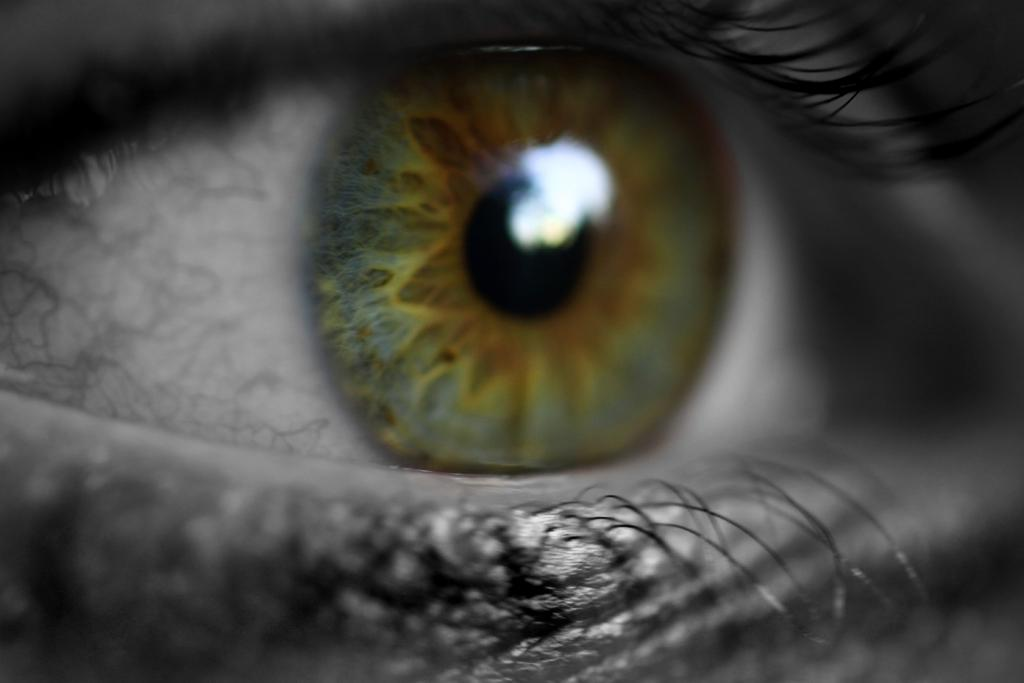What is the color scheme of the image? The image is black and white. What is the main subject of the image? There is an eye in the image. Are there any other features related to the eye in the image? Yes, there are eyelids in the image. Can you tell me how many thumbs are visible in the image? There are no thumbs present in the image; it features an eye and eyelids. What type of blade is being used in the image? There is no blade present in the image. 